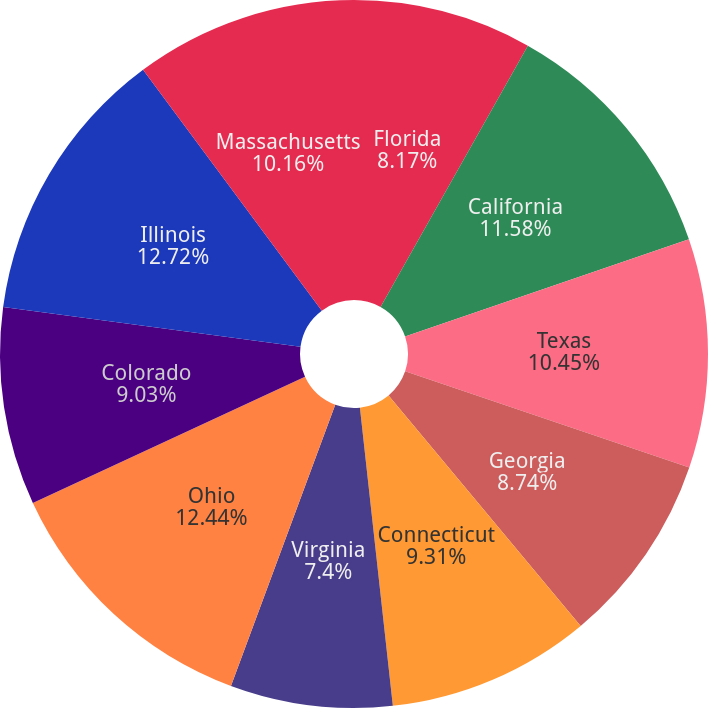Convert chart. <chart><loc_0><loc_0><loc_500><loc_500><pie_chart><fcel>Florida<fcel>California<fcel>Texas<fcel>Georgia<fcel>Connecticut<fcel>Virginia<fcel>Ohio<fcel>Colorado<fcel>Illinois<fcel>Massachusetts<nl><fcel>8.17%<fcel>11.58%<fcel>10.45%<fcel>8.74%<fcel>9.31%<fcel>7.4%<fcel>12.44%<fcel>9.03%<fcel>12.72%<fcel>10.16%<nl></chart> 